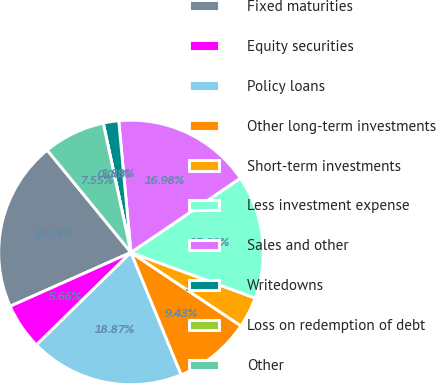Convert chart to OTSL. <chart><loc_0><loc_0><loc_500><loc_500><pie_chart><fcel>Fixed maturities<fcel>Equity securities<fcel>Policy loans<fcel>Other long-term investments<fcel>Short-term investments<fcel>Less investment expense<fcel>Sales and other<fcel>Writedowns<fcel>Loss on redemption of debt<fcel>Other<nl><fcel>20.75%<fcel>5.66%<fcel>18.87%<fcel>9.43%<fcel>3.77%<fcel>15.09%<fcel>16.98%<fcel>1.89%<fcel>0.0%<fcel>7.55%<nl></chart> 